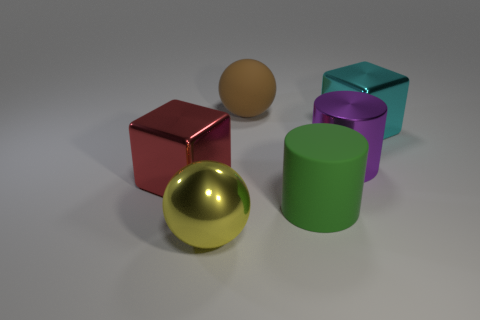Add 4 green balls. How many objects exist? 10 Subtract all blocks. How many objects are left? 4 Add 2 large red shiny things. How many large red shiny things are left? 3 Add 5 cyan shiny things. How many cyan shiny things exist? 6 Subtract 1 yellow spheres. How many objects are left? 5 Subtract 2 spheres. How many spheres are left? 0 Subtract all yellow cubes. Subtract all blue cylinders. How many cubes are left? 2 Subtract all big matte cylinders. Subtract all small purple metallic cylinders. How many objects are left? 5 